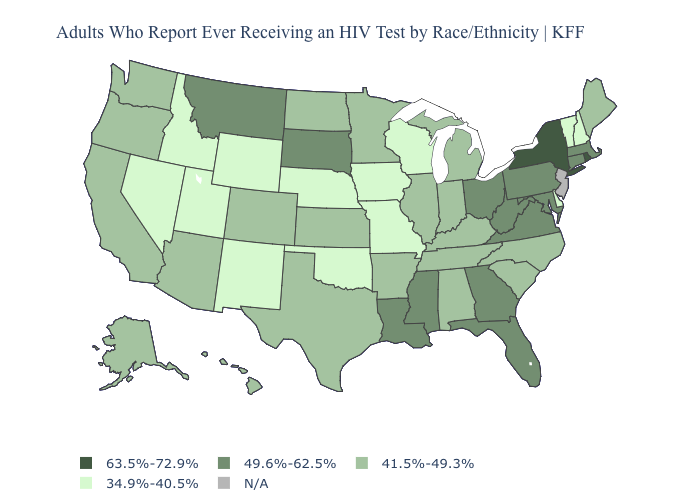Name the states that have a value in the range 49.6%-62.5%?
Write a very short answer. Connecticut, Florida, Georgia, Louisiana, Maryland, Massachusetts, Mississippi, Montana, Ohio, Pennsylvania, South Dakota, Virginia, West Virginia. Does the first symbol in the legend represent the smallest category?
Write a very short answer. No. Name the states that have a value in the range 41.5%-49.3%?
Answer briefly. Alabama, Alaska, Arizona, Arkansas, California, Colorado, Hawaii, Illinois, Indiana, Kansas, Kentucky, Maine, Michigan, Minnesota, North Carolina, North Dakota, Oregon, South Carolina, Tennessee, Texas, Washington. What is the value of North Dakota?
Short answer required. 41.5%-49.3%. Name the states that have a value in the range 49.6%-62.5%?
Give a very brief answer. Connecticut, Florida, Georgia, Louisiana, Maryland, Massachusetts, Mississippi, Montana, Ohio, Pennsylvania, South Dakota, Virginia, West Virginia. Among the states that border Massachusetts , which have the lowest value?
Keep it brief. New Hampshire, Vermont. What is the value of Arkansas?
Answer briefly. 41.5%-49.3%. Among the states that border Maryland , does Virginia have the lowest value?
Answer briefly. No. Among the states that border North Carolina , does Georgia have the highest value?
Quick response, please. Yes. Name the states that have a value in the range 49.6%-62.5%?
Concise answer only. Connecticut, Florida, Georgia, Louisiana, Maryland, Massachusetts, Mississippi, Montana, Ohio, Pennsylvania, South Dakota, Virginia, West Virginia. What is the value of Iowa?
Concise answer only. 34.9%-40.5%. What is the lowest value in states that border Connecticut?
Keep it brief. 49.6%-62.5%. Which states have the lowest value in the Northeast?
Be succinct. New Hampshire, Vermont. 